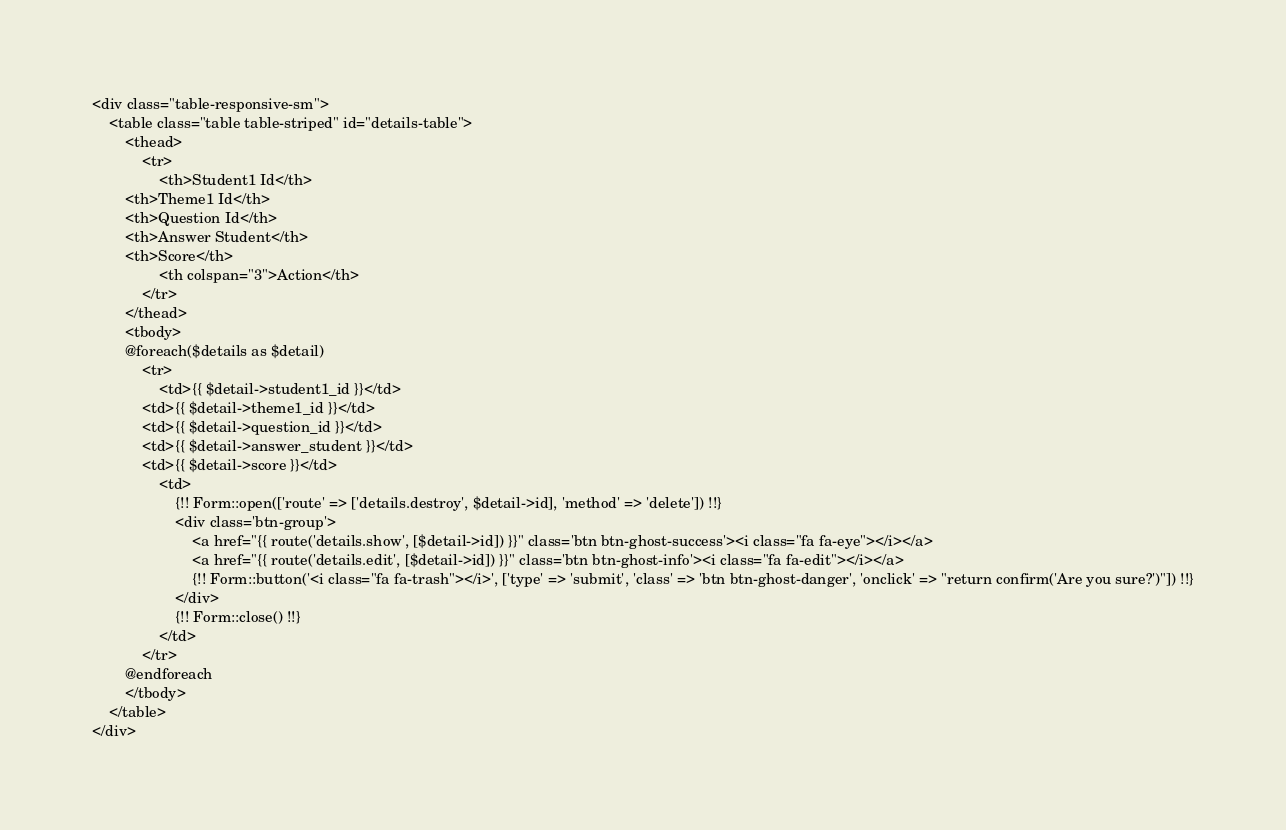<code> <loc_0><loc_0><loc_500><loc_500><_PHP_><div class="table-responsive-sm">
    <table class="table table-striped" id="details-table">
        <thead>
            <tr>
                <th>Student1 Id</th>
        <th>Theme1 Id</th>
        <th>Question Id</th>
        <th>Answer Student</th>
        <th>Score</th>
                <th colspan="3">Action</th>
            </tr>
        </thead>
        <tbody>
        @foreach($details as $detail)
            <tr>
                <td>{{ $detail->student1_id }}</td>
            <td>{{ $detail->theme1_id }}</td>
            <td>{{ $detail->question_id }}</td>
            <td>{{ $detail->answer_student }}</td>
            <td>{{ $detail->score }}</td>
                <td>
                    {!! Form::open(['route' => ['details.destroy', $detail->id], 'method' => 'delete']) !!}
                    <div class='btn-group'>
                        <a href="{{ route('details.show', [$detail->id]) }}" class='btn btn-ghost-success'><i class="fa fa-eye"></i></a>
                        <a href="{{ route('details.edit', [$detail->id]) }}" class='btn btn-ghost-info'><i class="fa fa-edit"></i></a>
                        {!! Form::button('<i class="fa fa-trash"></i>', ['type' => 'submit', 'class' => 'btn btn-ghost-danger', 'onclick' => "return confirm('Are you sure?')"]) !!}
                    </div>
                    {!! Form::close() !!}
                </td>
            </tr>
        @endforeach
        </tbody>
    </table>
</div></code> 